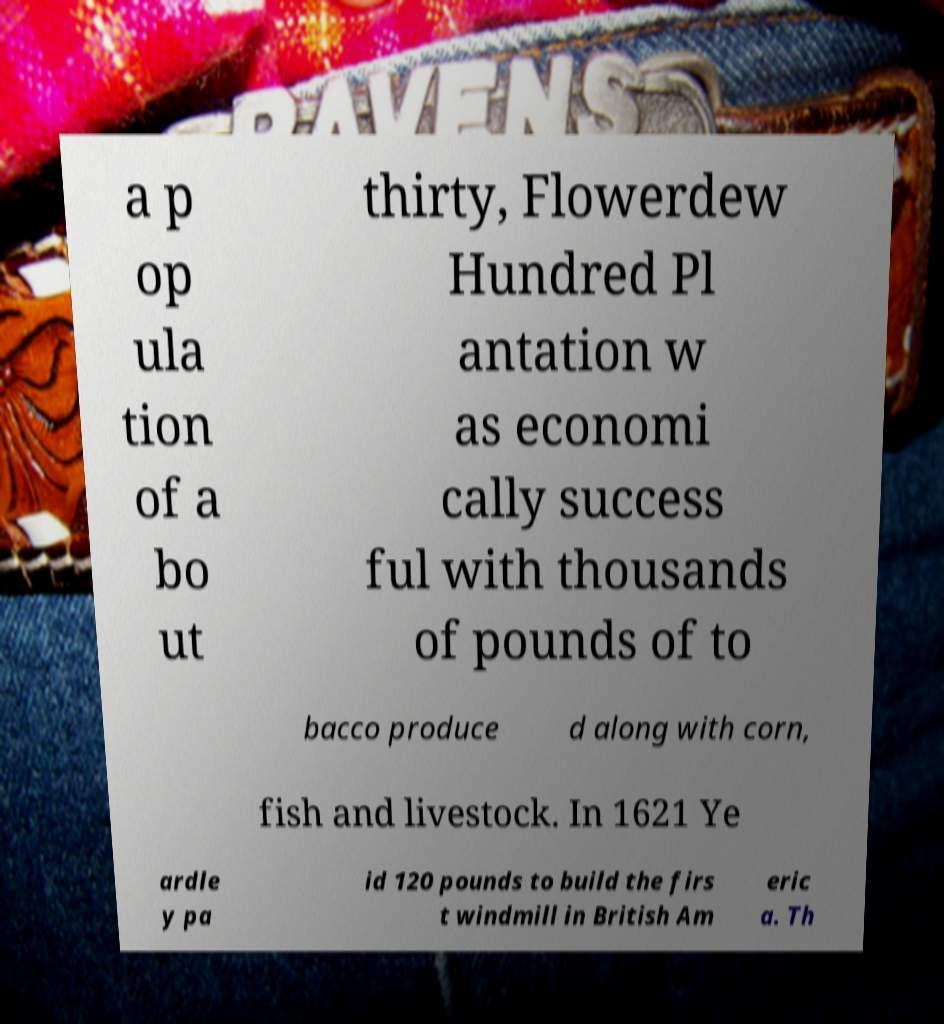Please read and relay the text visible in this image. What does it say? a p op ula tion of a bo ut thirty, Flowerdew Hundred Pl antation w as economi cally success ful with thousands of pounds of to bacco produce d along with corn, fish and livestock. In 1621 Ye ardle y pa id 120 pounds to build the firs t windmill in British Am eric a. Th 